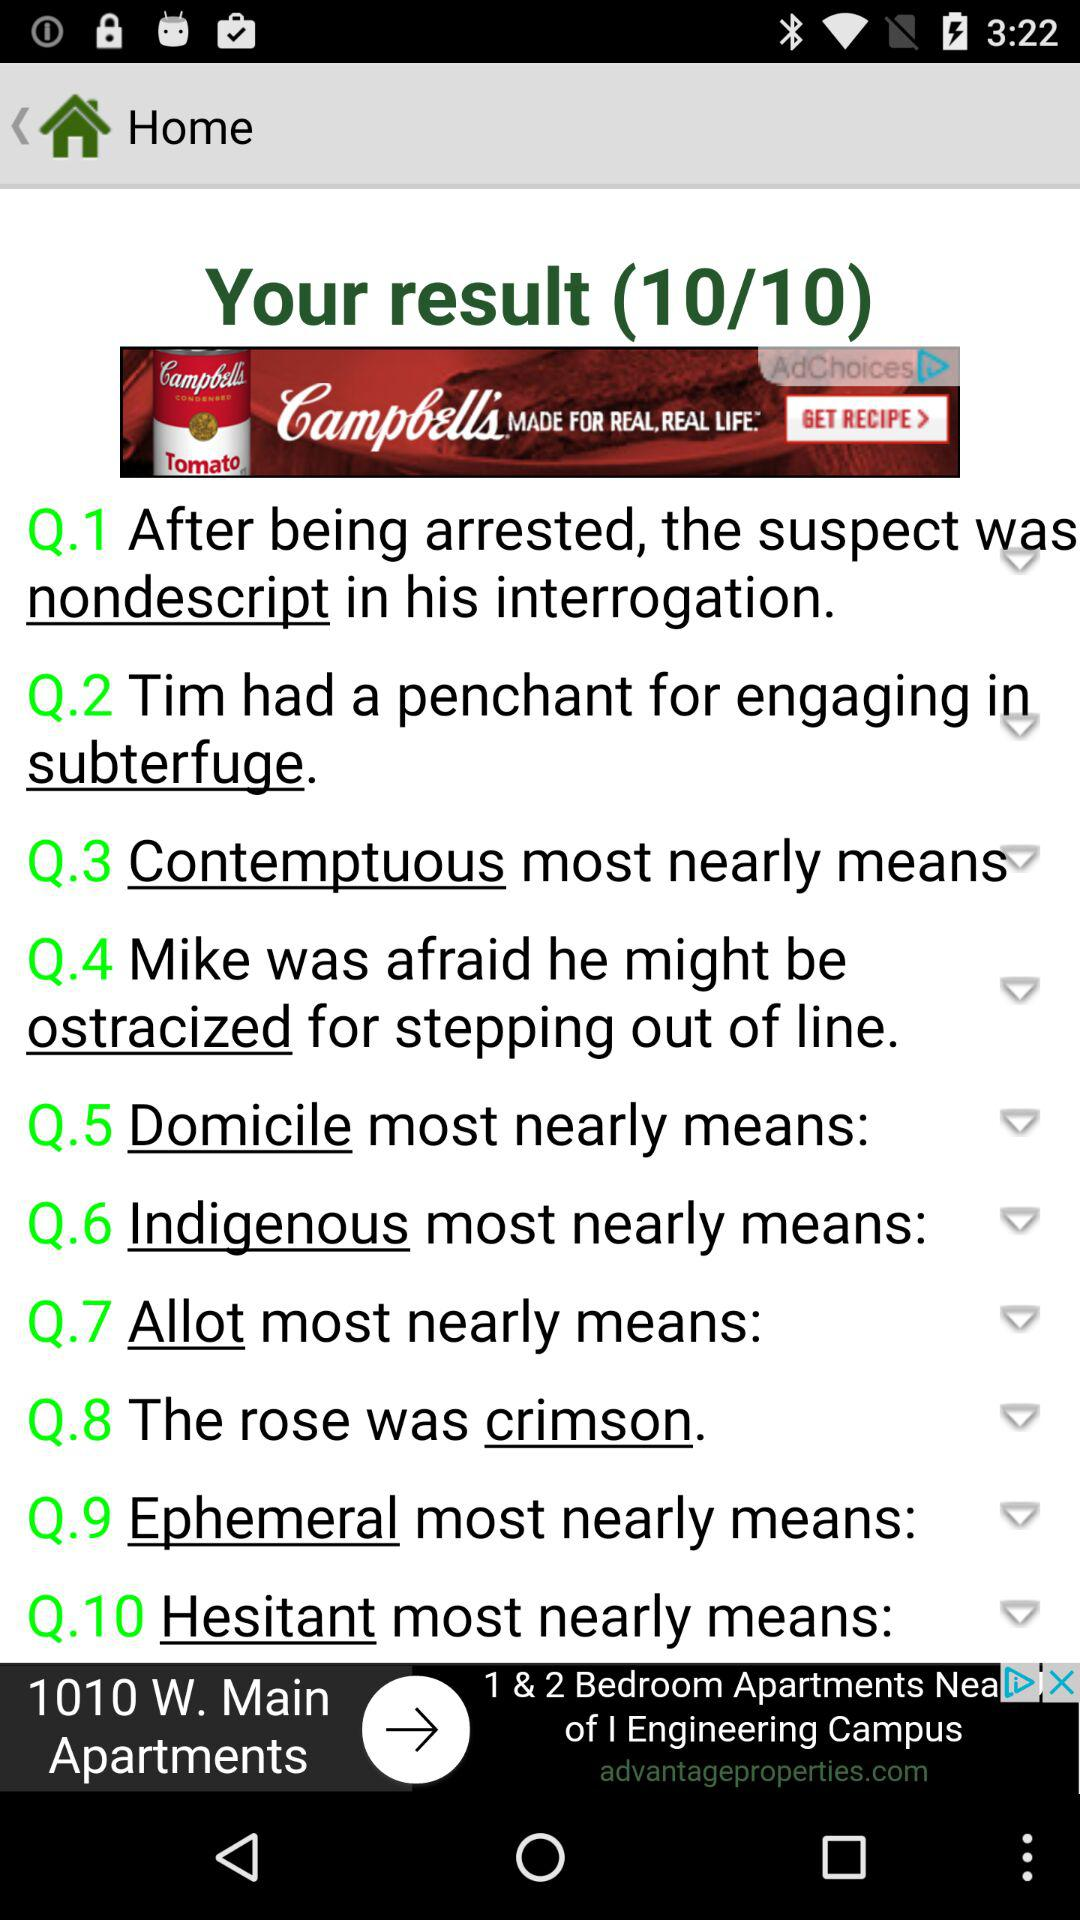How many questions in total are there? There are 10 questions. 